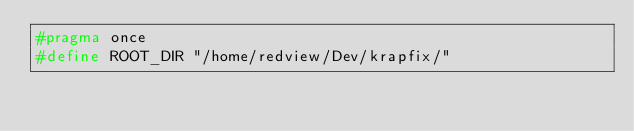Convert code to text. <code><loc_0><loc_0><loc_500><loc_500><_C_>#pragma once
#define ROOT_DIR "/home/redview/Dev/krapfix/"
</code> 